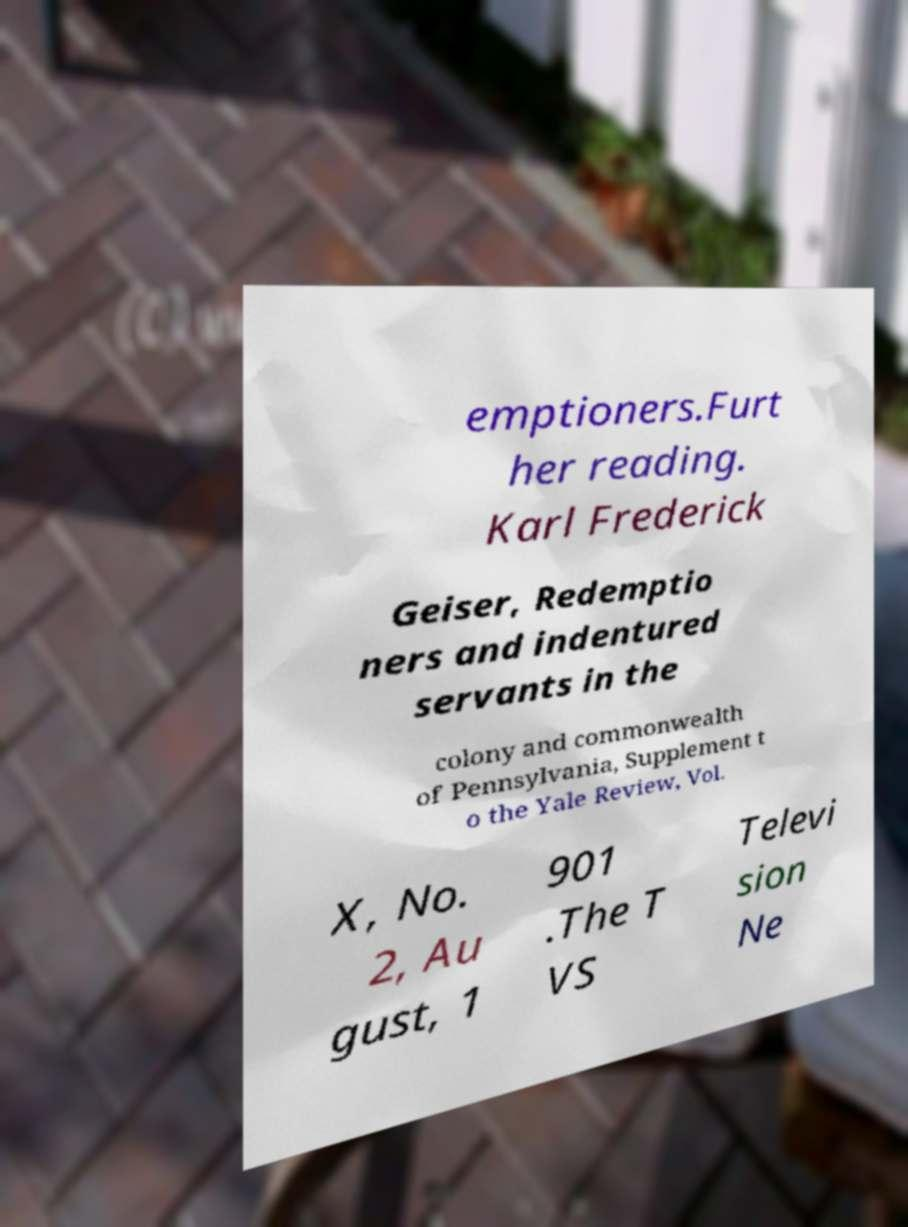What messages or text are displayed in this image? I need them in a readable, typed format. emptioners.Furt her reading. Karl Frederick Geiser, Redemptio ners and indentured servants in the colony and commonwealth of Pennsylvania, Supplement t o the Yale Review, Vol. X, No. 2, Au gust, 1 901 .The T VS Televi sion Ne 